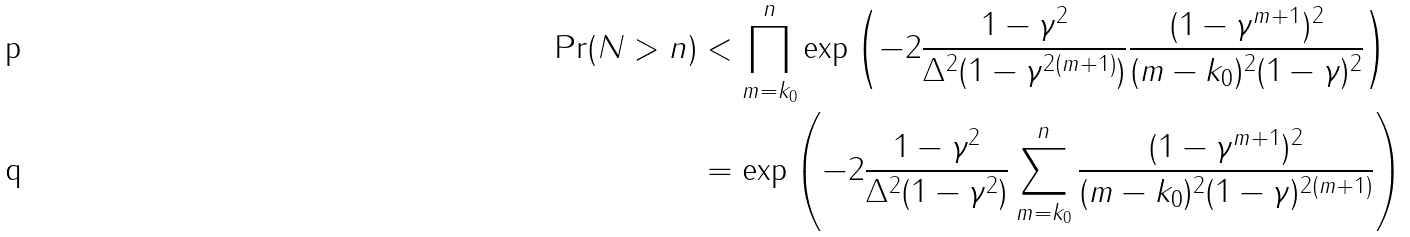<formula> <loc_0><loc_0><loc_500><loc_500>\Pr ( N > n ) & < \prod _ { m = k _ { 0 } } ^ { n } \exp \left ( - 2 \frac { 1 - \gamma ^ { 2 } } { \Delta ^ { 2 } ( 1 - \gamma ^ { 2 ( m + 1 ) } ) } \frac { ( 1 - \gamma ^ { m + 1 } ) ^ { 2 } } { ( m - k _ { 0 } ) ^ { 2 } ( 1 - \gamma ) ^ { 2 } } \right ) \\ & = \exp \left ( - 2 \frac { 1 - \gamma ^ { 2 } } { \Delta ^ { 2 } ( 1 - \gamma ^ { 2 } ) } \sum _ { m = k _ { 0 } } ^ { n } \frac { ( 1 - \gamma ^ { m + 1 } ) ^ { 2 } } { ( m - k _ { 0 } ) ^ { 2 } ( 1 - \gamma ) ^ { 2 ( m + 1 ) } } \right )</formula> 